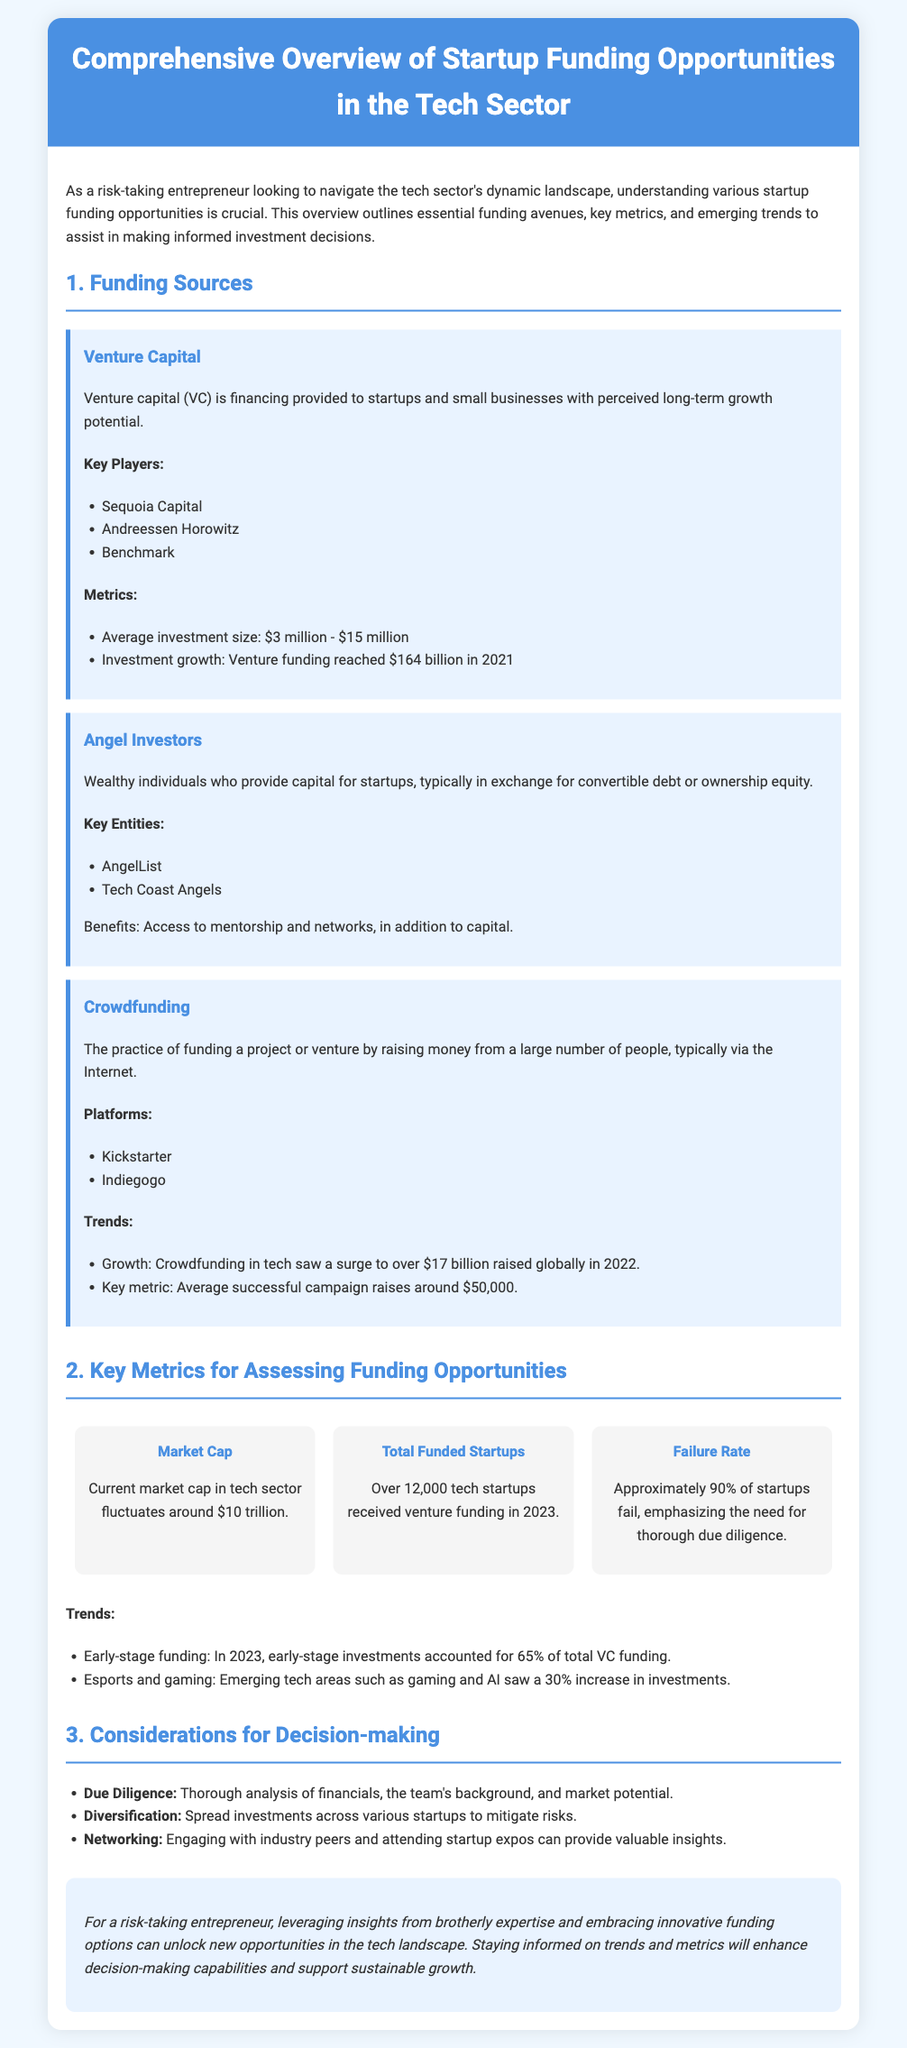What is the average investment size for venture capital? The average investment size for venture capital ranges between $3 million to $15 million.
Answer: $3 million - $15 million How much did venture funding reach in 2021? The document states that venture funding reached $164 billion in 2021.
Answer: $164 billion What was the total amount raised in Crowdfunding for tech in 2022? The overview mentions that crowdfunding in tech saw over $17 billion raised globally in 2022.
Answer: Over $17 billion What percentage of total VC funding did early-stage investments account for in 2023? According to the document, early-stage investments accounted for 65% of total VC funding in 2023.
Answer: 65% What is the current market cap in the tech sector? The document indicates that the current market cap in the tech sector fluctuates around $10 trillion.
Answer: $10 trillion Which two platforms are mentioned for crowdfunding? The platforms for crowdfunding listed in the document are Kickstarter and Indiegogo.
Answer: Kickstarter, Indiegogo What is the failure rate of startups? The document reports that approximately 90% of startups fail, emphasizing the need for due diligence.
Answer: Approximately 90% Which tech areas saw a 30% increase in investments? The document identifies esports and gaming as the emerging tech areas that saw a 30% increase in investments.
Answer: Esports and gaming 